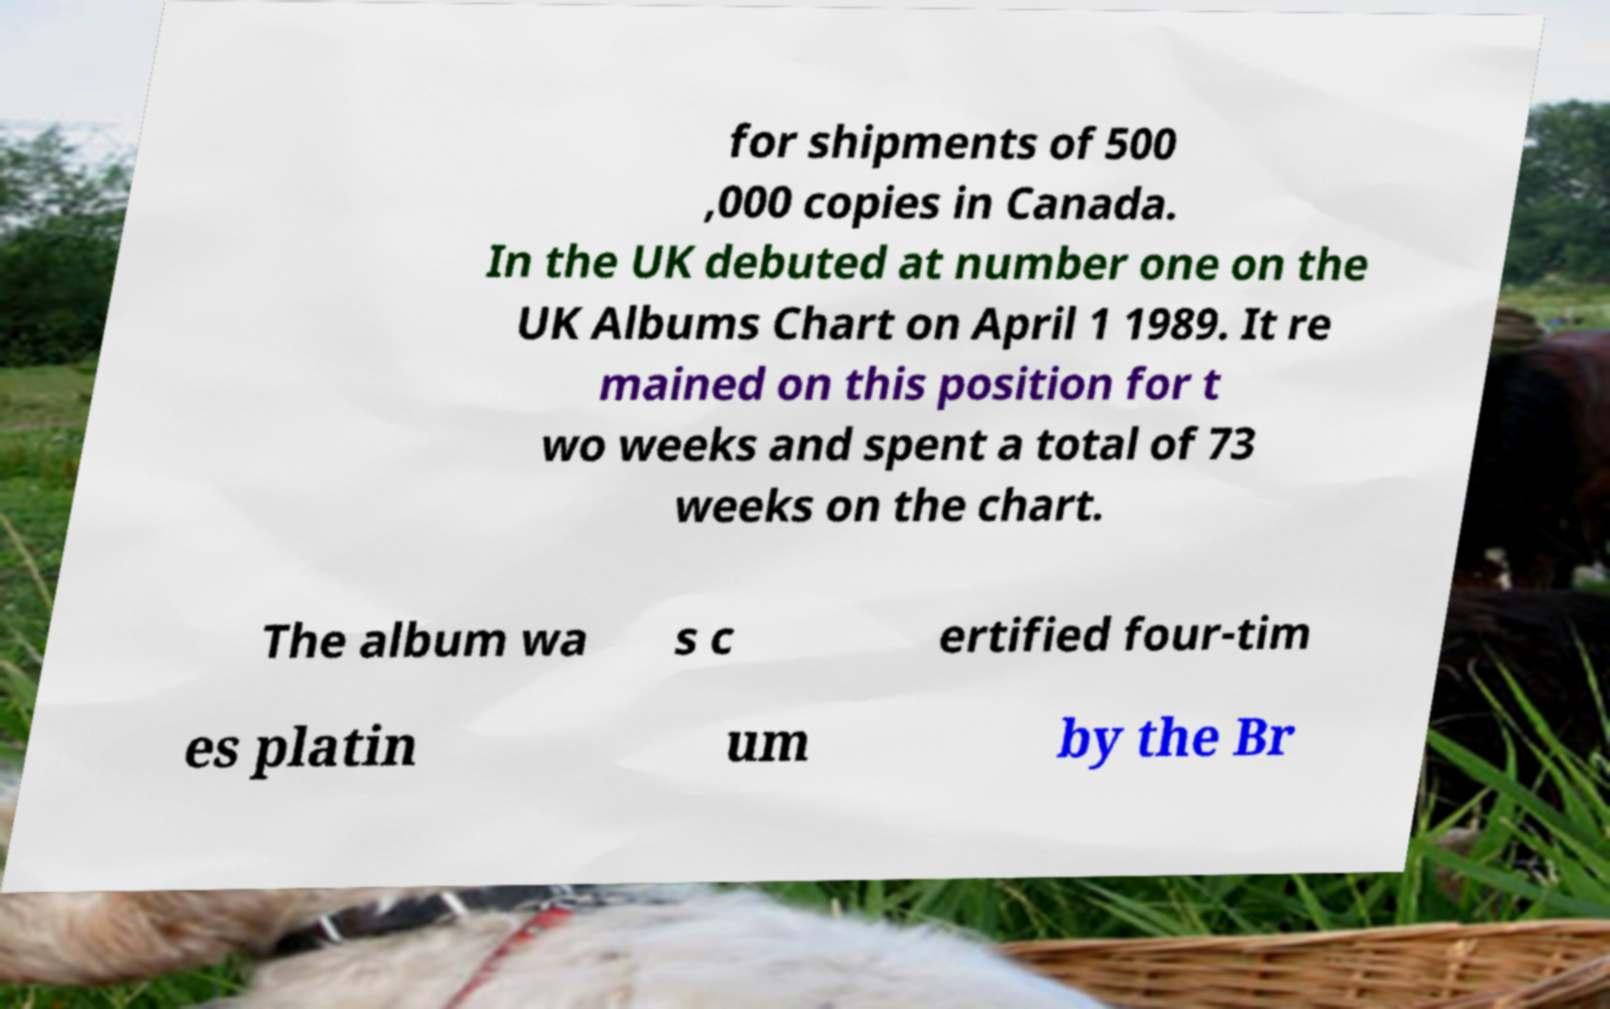What messages or text are displayed in this image? I need them in a readable, typed format. for shipments of 500 ,000 copies in Canada. In the UK debuted at number one on the UK Albums Chart on April 1 1989. It re mained on this position for t wo weeks and spent a total of 73 weeks on the chart. The album wa s c ertified four-tim es platin um by the Br 